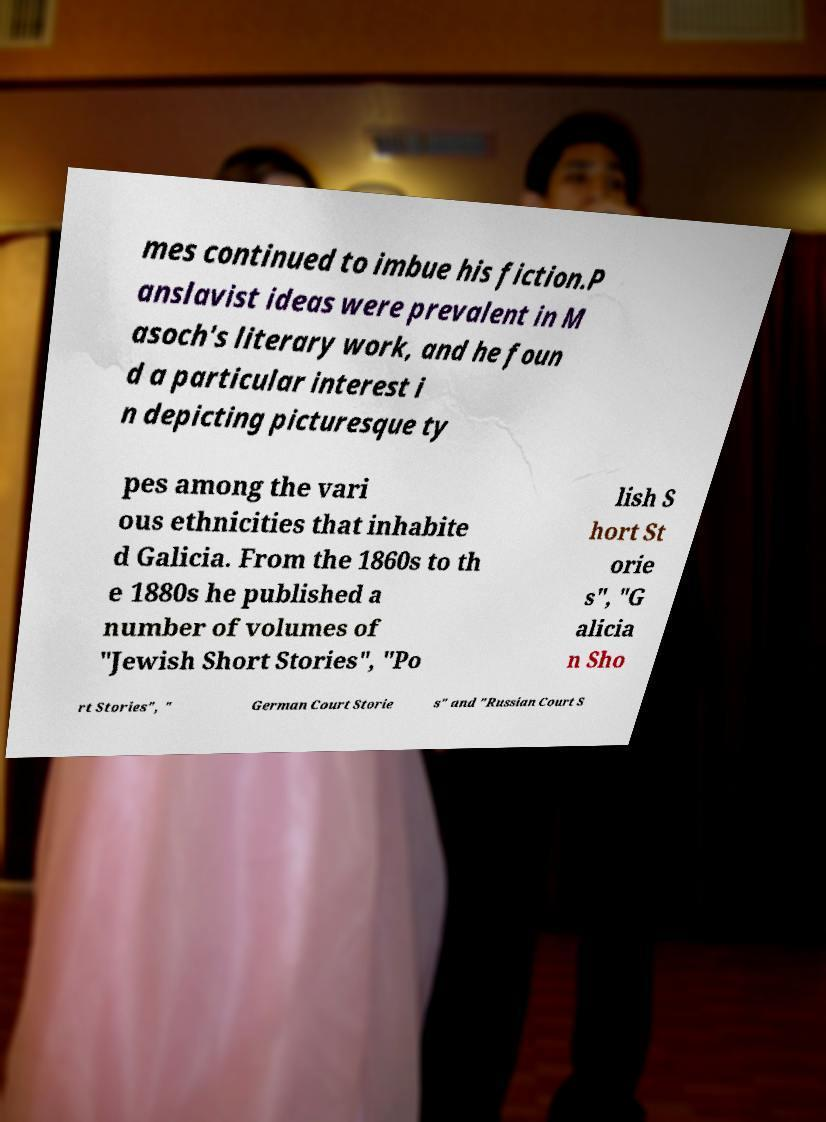Please read and relay the text visible in this image. What does it say? mes continued to imbue his fiction.P anslavist ideas were prevalent in M asoch's literary work, and he foun d a particular interest i n depicting picturesque ty pes among the vari ous ethnicities that inhabite d Galicia. From the 1860s to th e 1880s he published a number of volumes of "Jewish Short Stories", "Po lish S hort St orie s", "G alicia n Sho rt Stories", " German Court Storie s" and "Russian Court S 